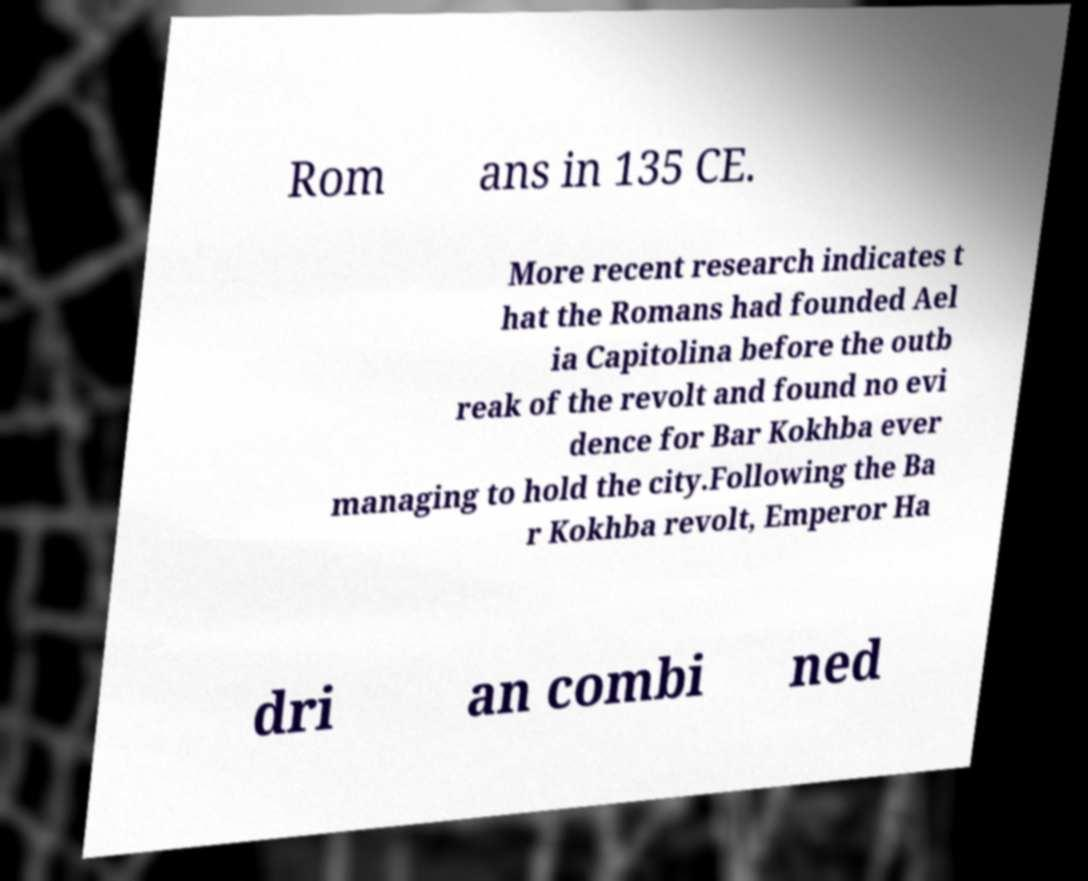Please identify and transcribe the text found in this image. Rom ans in 135 CE. More recent research indicates t hat the Romans had founded Ael ia Capitolina before the outb reak of the revolt and found no evi dence for Bar Kokhba ever managing to hold the city.Following the Ba r Kokhba revolt, Emperor Ha dri an combi ned 